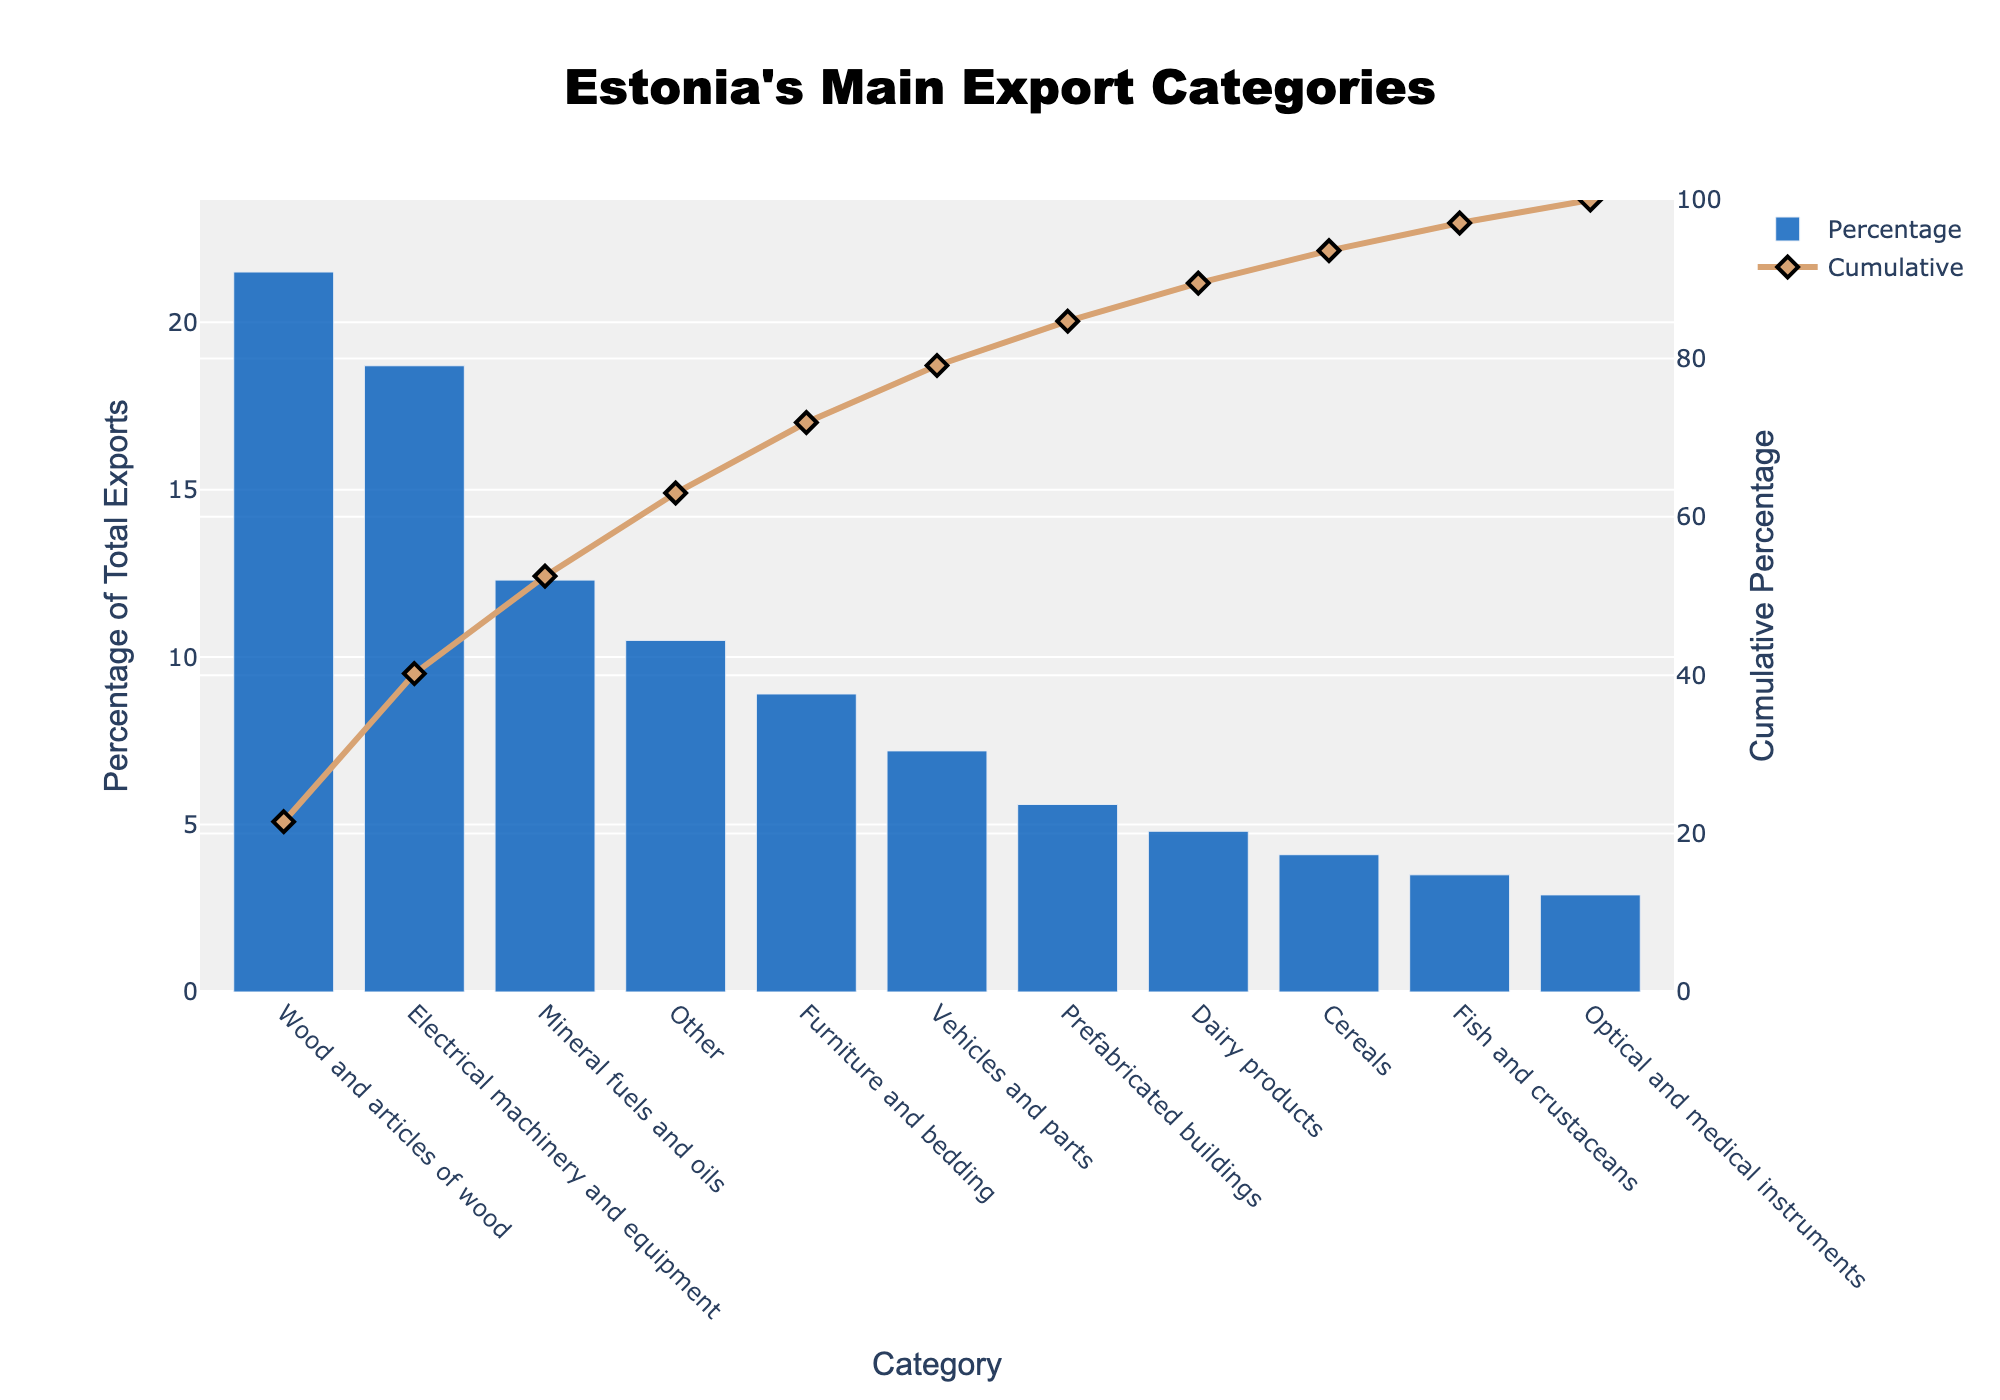What is the category with the highest percentage of total exports? The category with the highest bar indicates the highest percentage of total exports, which is "Wood and articles of wood" at 21.5%.
Answer: Wood and articles of wood What is the cumulative percentage after the third category? Sum the percentages of the first three categories: Wood and articles of wood (21.5%), Electrical machinery and equipment (18.7%), and Mineral fuels and oils (12.3%). This gives 21.5 + 18.7 + 12.3 = 52.5%.
Answer: 52.5% Which category has a higher export percentage: Furniture and bedding or Vehicles and parts? Compare the percentages of the two categories: Furniture and bedding is 8.9% and Vehicles and parts is 7.2%. Furniture and bedding has a higher percentage.
Answer: Furniture and bedding What is the total percentage of the top five export categories? Sum the percentages of the top five categories: 21.5 (Wood), 18.7 (Electrical machinery), 12.3 (Mineral fuels), 8.9 (Furniture), and 7.2 (Vehicles). This gives 21.5 + 18.7 + 12.3 + 8.9 + 7.2 = 68.6%.
Answer: 68.6% Which export category contributes nearly 50% to the cumulative percentage on its own? The category closest to 50% cumulative percentage is "Wood and articles of wood" with 21.5%. No single category reaches 50%, but "Wood and articles of wood" contributes significantly.
Answer: Wood and articles of wood What is the percentage of the "Other" category, and where does it rank in terms of export percentage? The percentage of the "Other" category is 10.5%, making it the 4th largest in terms of export percentage.
Answer: 10.5%, 4th Is the percentage contribution of "Fish and crustaceans" greater than "Cereals"? The percentage for "Fish and crustaceans" is 3.5%, while for "Cereals" it is 4.1%. Therefore, "Cereals" has a greater percentage.
Answer: No What is the cumulative percentage reaching up to "Prefabricated buildings"? Sum the percentages from "Wood and articles of wood" to "Prefabricated buildings": 21.5 + 18.7 + 12.3 + 8.9 + 7.2 + 5.6 = 74.2%.
Answer: 74.2% How much higher is the percentage of "Dairy products" compared to "Optical and medical instruments"? Subtract the percentage of "Optical and medical instruments" (2.9%) from "Dairy products" (4.8%): 4.8 - 2.9 = 1.9%.
Answer: 1.9% higher 